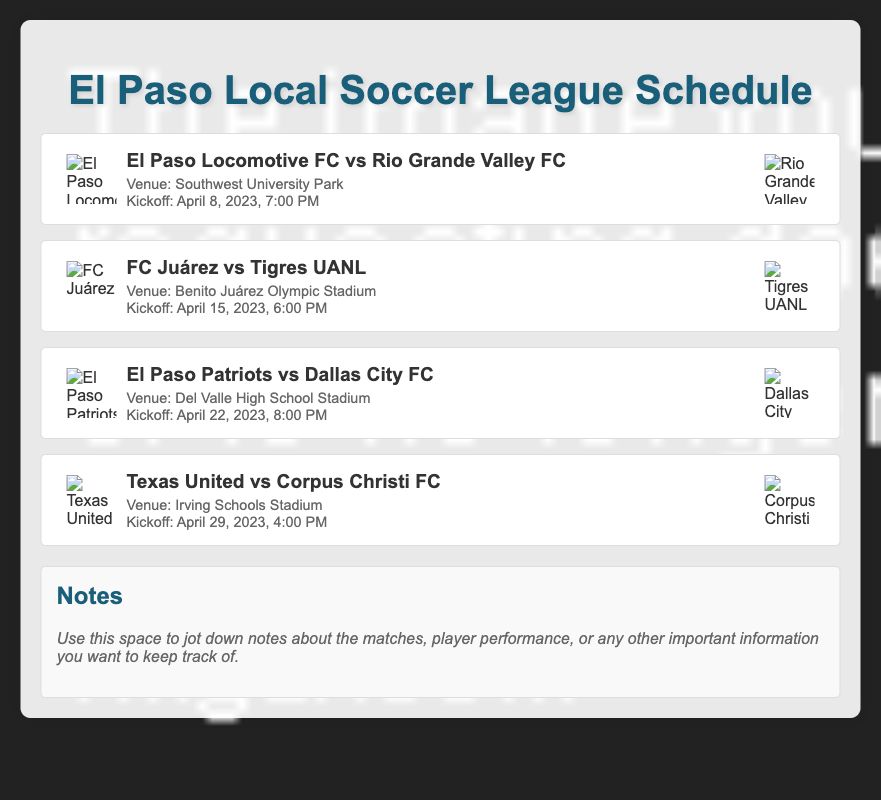What is the title of the document? The title of the document is prominent at the top and introduces the content.
Answer: El Paso Local Soccer League Schedule How many matches are listed in the document? Each match is detailed in its own section, allowing for a count of the matches presented.
Answer: 4 What is the date and time of the match between El Paso Locomotive FC and Rio Grande Valley FC? The date and time are provided alongside the details of the match in the document.
Answer: April 8, 2023, 7:00 PM Where is the match between FC Juárez and Tigres UANL taking place? The venue information is specified for each match, providing the location for this match.
Answer: Benito Juárez Olympic Stadium Which two teams are playing on April 29, 2023? The concise team names for the specific date are listed in the match's detail section.
Answer: Texas United vs Corpus Christi FC Which venue is used for the El Paso Patriots match? The venue details for each match clarify where it will occur, leading to this specific answer.
Answer: Del Valle High School Stadium Which match has the earliest kickoff time? By comparing the kickoff times across the matches listed, one can deduce which comes first.
Answer: El Paso Locomotive FC vs Rio Grande Valley FC What section is provided for additional thoughts in the document? The document includes space for notes, allowing fans to write down impressions or reminders post-match.
Answer: Notes 